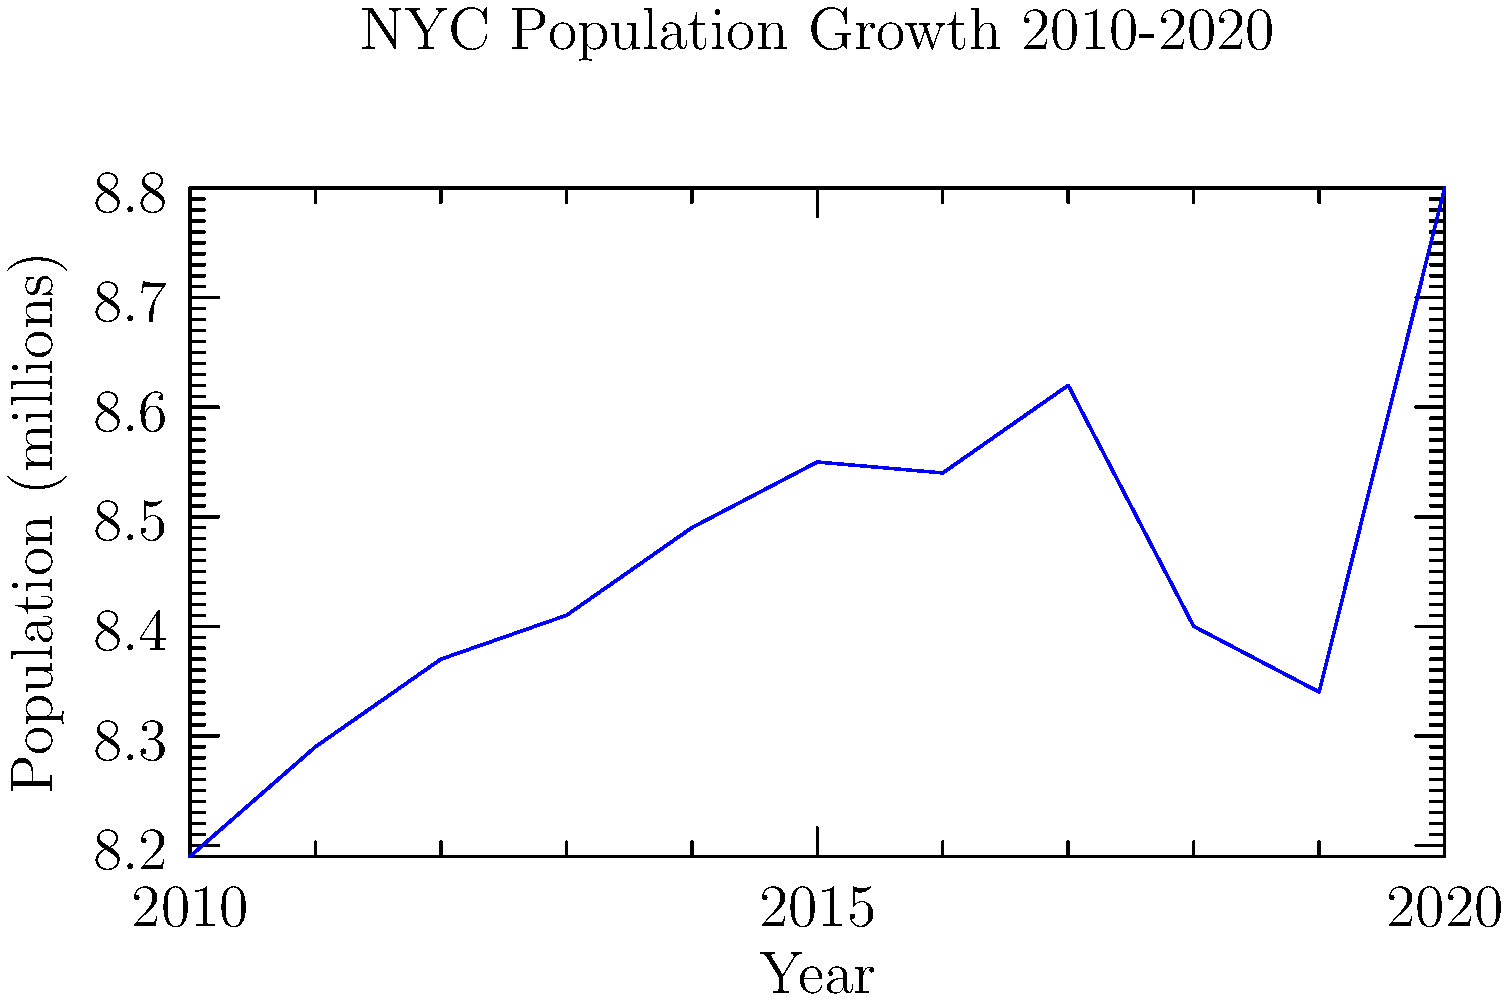Based on the line graph showing New York City's population growth from 2010 to 2020, in which year did the city experience the most significant population decline compared to the previous year? To answer this question, we need to analyze the line graph step-by-step:

1. Examine the general trend: The graph shows an overall increasing trend in NYC's population from 2010 to 2020.

2. Identify periods of decline: There are two noticeable declines in the graph:
   a) Between 2015 and 2016
   b) Between 2017 and 2019

3. Compare the declines:
   a) The decline from 2015 to 2016 is relatively small.
   b) The decline from 2017 to 2018 is more substantial.

4. Quantify the decline from 2017 to 2018:
   Population in 2017: approximately 8.62 million
   Population in 2018: approximately 8.40 million
   Decline: 8.62 - 8.40 = 0.22 million (or 220,000 people)

5. Verify that this is the largest decline in the given period:
   No other year-to-year change shows a larger decrease in population.

Therefore, the most significant population decline occurred from 2017 to 2018.
Answer: 2018 